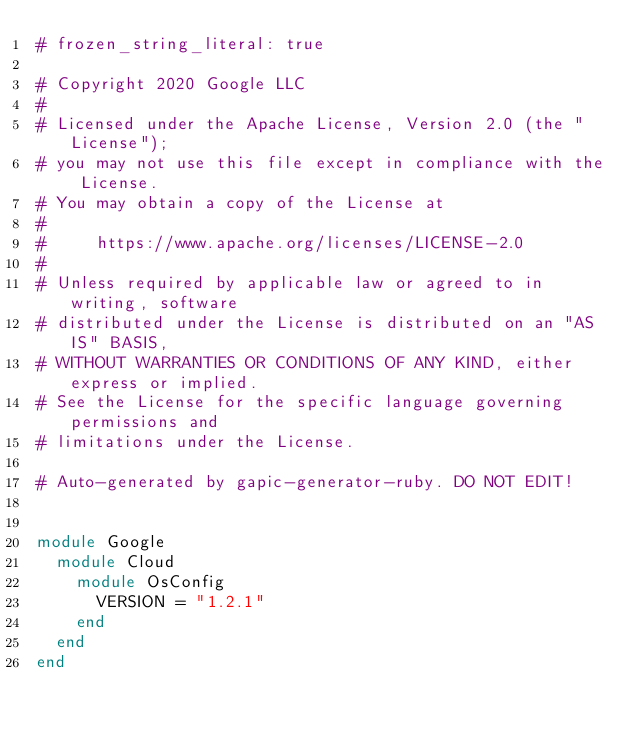<code> <loc_0><loc_0><loc_500><loc_500><_Ruby_># frozen_string_literal: true

# Copyright 2020 Google LLC
#
# Licensed under the Apache License, Version 2.0 (the "License");
# you may not use this file except in compliance with the License.
# You may obtain a copy of the License at
#
#     https://www.apache.org/licenses/LICENSE-2.0
#
# Unless required by applicable law or agreed to in writing, software
# distributed under the License is distributed on an "AS IS" BASIS,
# WITHOUT WARRANTIES OR CONDITIONS OF ANY KIND, either express or implied.
# See the License for the specific language governing permissions and
# limitations under the License.

# Auto-generated by gapic-generator-ruby. DO NOT EDIT!


module Google
  module Cloud
    module OsConfig
      VERSION = "1.2.1"
    end
  end
end
</code> 